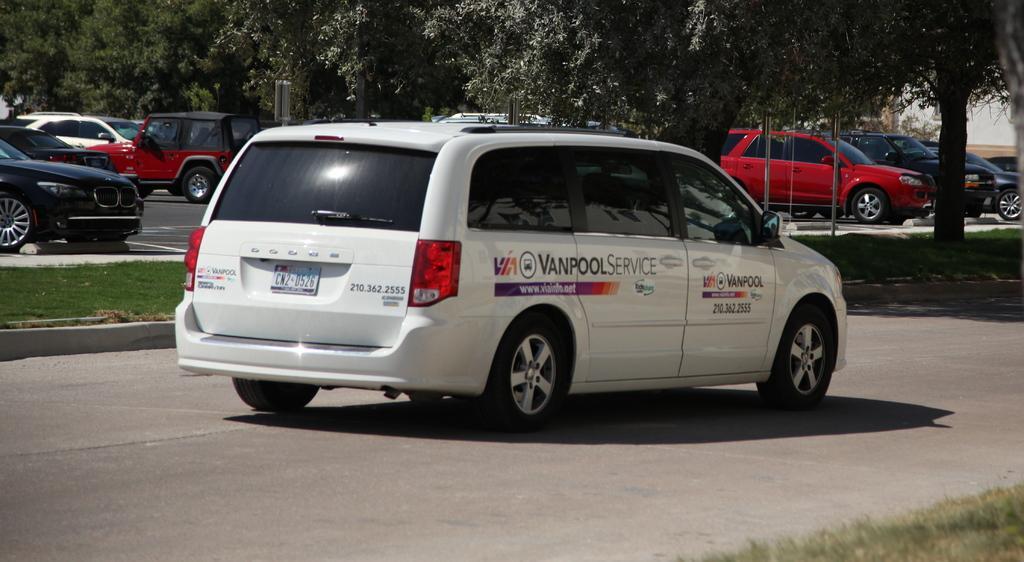Can you describe this image briefly? In this image I can see few vehicles. In front the vehicle is in white color, background I can see trees in green color and a building in white color. 